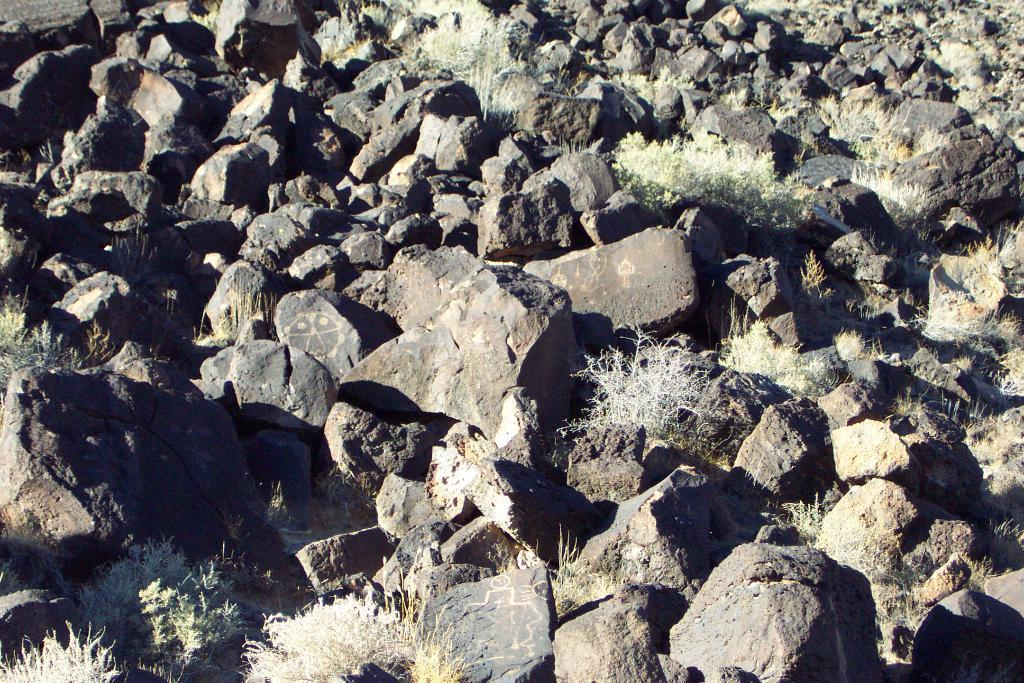What type of natural elements can be seen in the image? There are rocks and plants in the image. Can you describe the rocks in the image? The rocks in the image are likely part of a landscape or natural setting. What type of plants are visible in the image? The plants in the image could be various types, such as trees, bushes, or flowers. What type of breakfast is being served in the image? There is no breakfast present in the image; it only features rocks and plants. Can you hear any noise coming from the image? The image is silent, as it is a still photograph and does not contain any audio. 